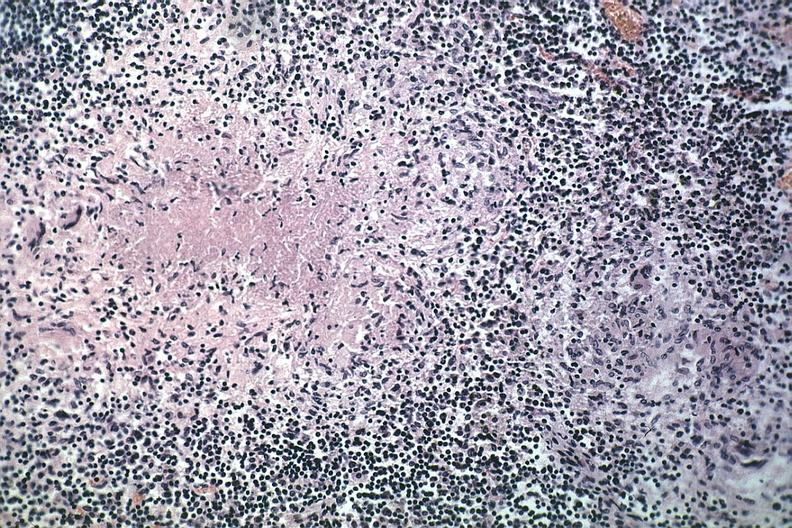what does this image show?
Answer the question using a single word or phrase. Typical area of caseous necrosis with nearby early granuloma quite good source unknown 